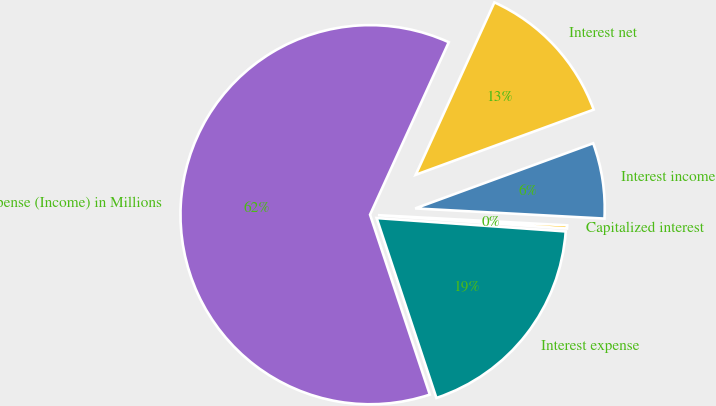<chart> <loc_0><loc_0><loc_500><loc_500><pie_chart><fcel>Expense (Income) in Millions<fcel>Interest expense<fcel>Capitalized interest<fcel>Interest income<fcel>Interest net<nl><fcel>61.92%<fcel>18.77%<fcel>0.27%<fcel>6.44%<fcel>12.6%<nl></chart> 